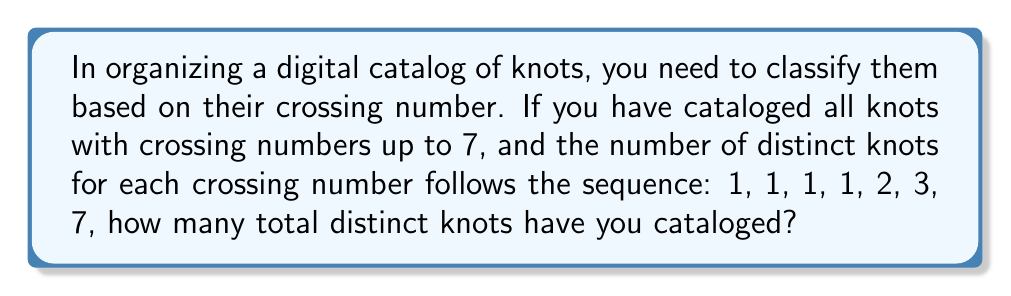Teach me how to tackle this problem. Let's approach this step-by-step:

1) First, let's understand what the sequence represents:
   - 1 knot with 0 crossings (the unknot)
   - 1 knot with 1 crossing
   - 1 knot with 2 crossings
   - 1 knot with 3 crossings
   - 2 knots with 4 crossings
   - 3 knots with 5 crossings
   - 7 knots with 6 crossings
   - The question states "up to 7", so we include all of these

2) To find the total number of distinct knots, we need to sum this sequence:

   $$\sum_{i=0}^6 k_i$$

   where $k_i$ is the number of knots with $i$ crossings.

3) Let's perform the sum:

   $$1 + 1 + 1 + 1 + 2 + 3 + 7 = 16$$

Therefore, the total number of distinct knots cataloged is 16.
Answer: 16 